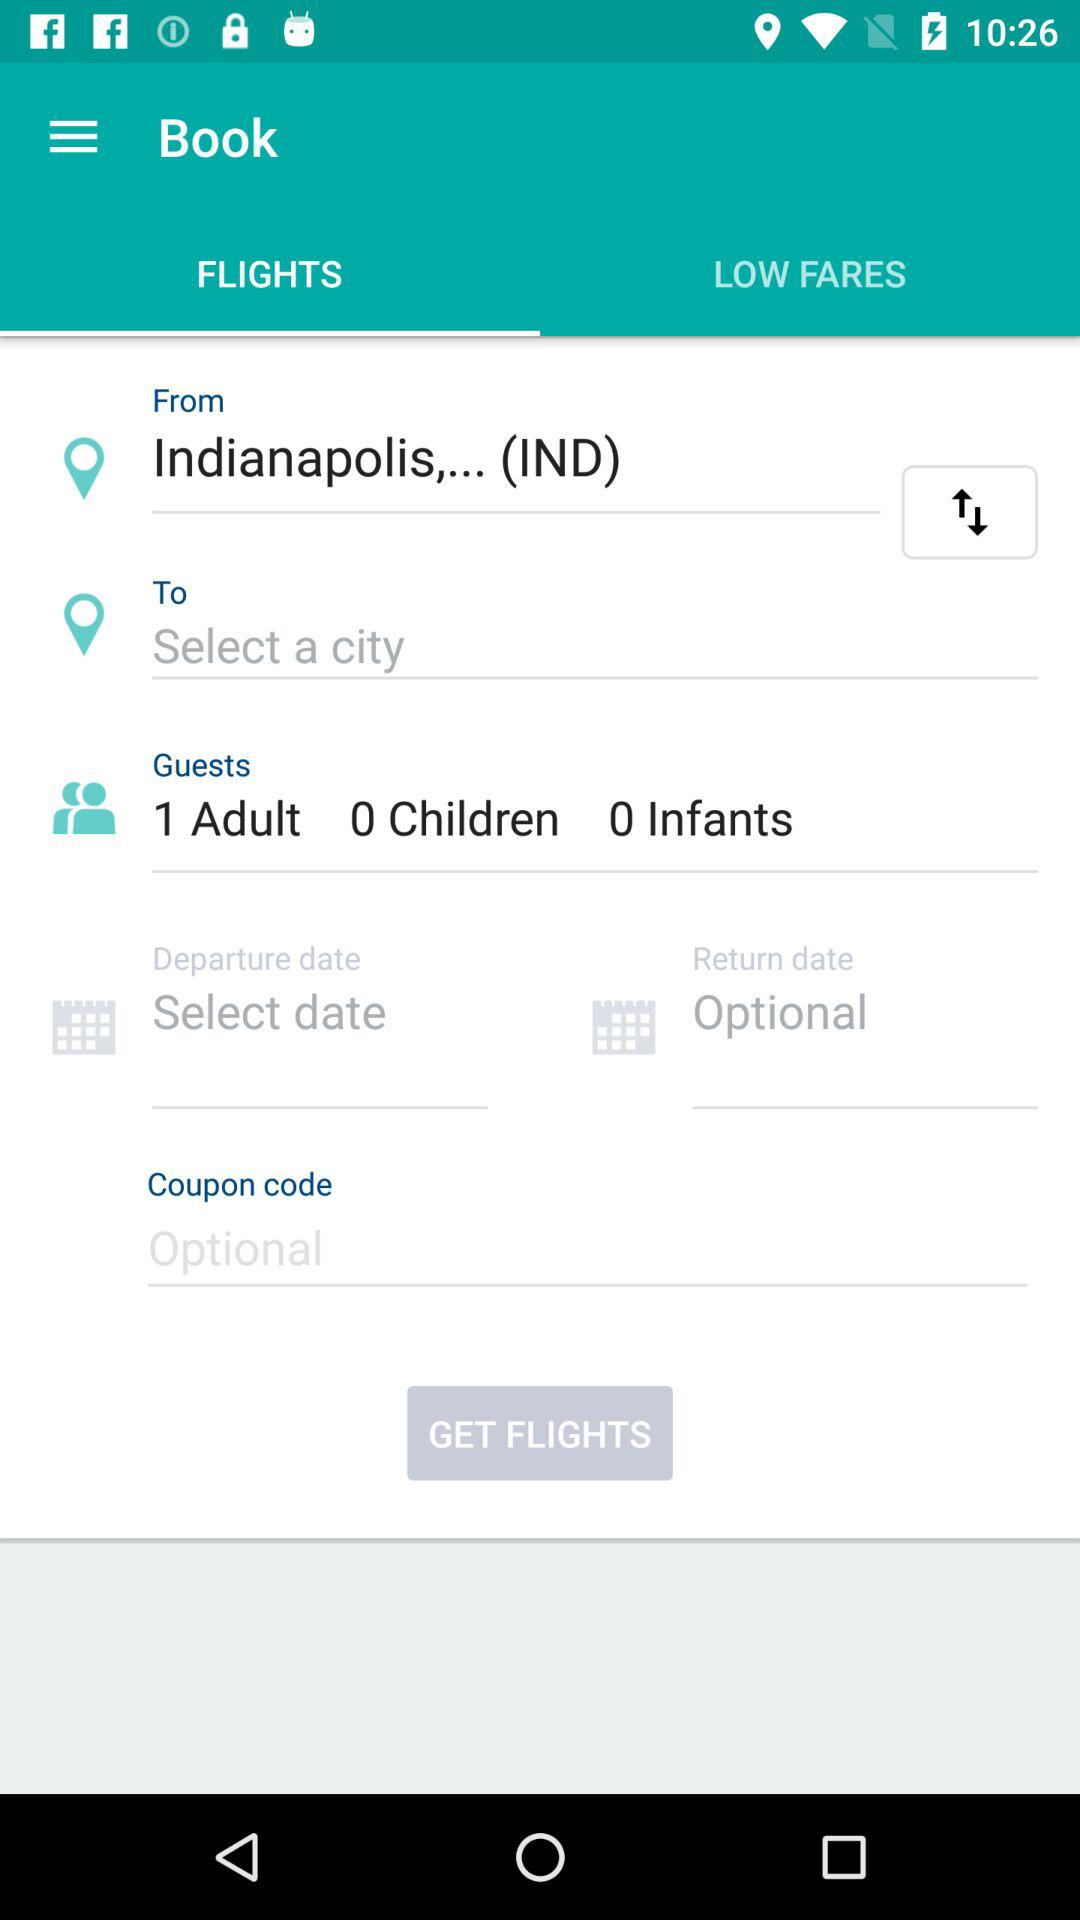How many more guests are there than infants?
Answer the question using a single word or phrase. 1 